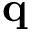<formula> <loc_0><loc_0><loc_500><loc_500>\mathbf q</formula> 